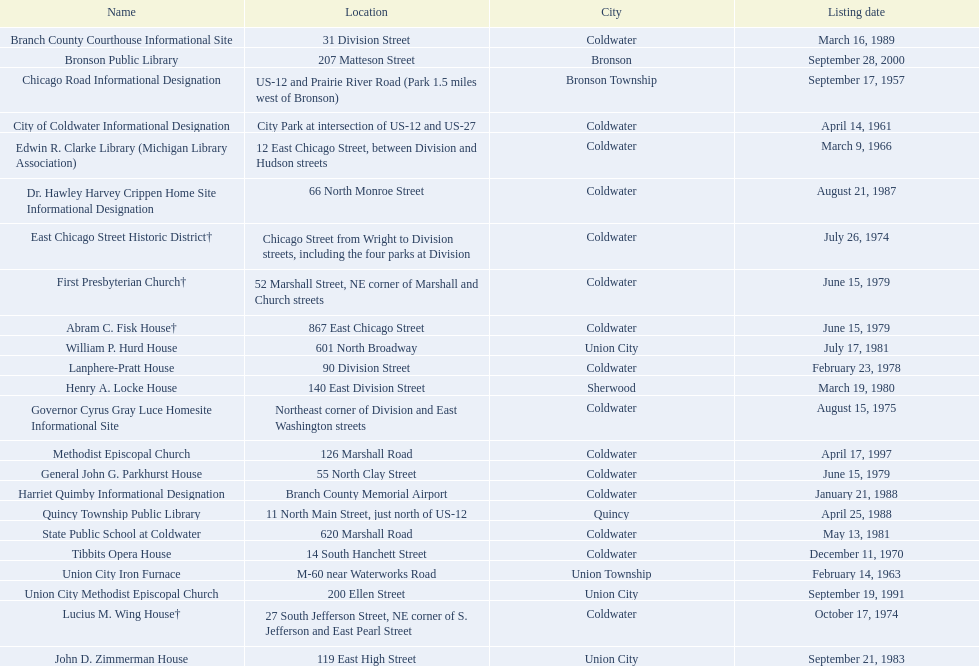What are all the spots deemed historical sites in branch county, michigan? Branch County Courthouse Informational Site, Bronson Public Library, Chicago Road Informational Designation, City of Coldwater Informational Designation, Edwin R. Clarke Library (Michigan Library Association), Dr. Hawley Harvey Crippen Home Site Informational Designation, East Chicago Street Historic District†, First Presbyterian Church†, Abram C. Fisk House†, William P. Hurd House, Lanphere-Pratt House, Henry A. Locke House, Governor Cyrus Gray Luce Homesite Informational Site, Methodist Episcopal Church, General John G. Parkhurst House, Harriet Quimby Informational Designation, Quincy Township Public Library, State Public School at Coldwater, Tibbits Opera House, Union City Iron Furnace, Union City Methodist Episcopal Church, Lucius M. Wing House†, John D. Zimmerman House. Out of those sites, which one was first to be recognized as historical? Chicago Road Informational Designation. 